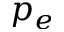<formula> <loc_0><loc_0><loc_500><loc_500>p _ { e }</formula> 